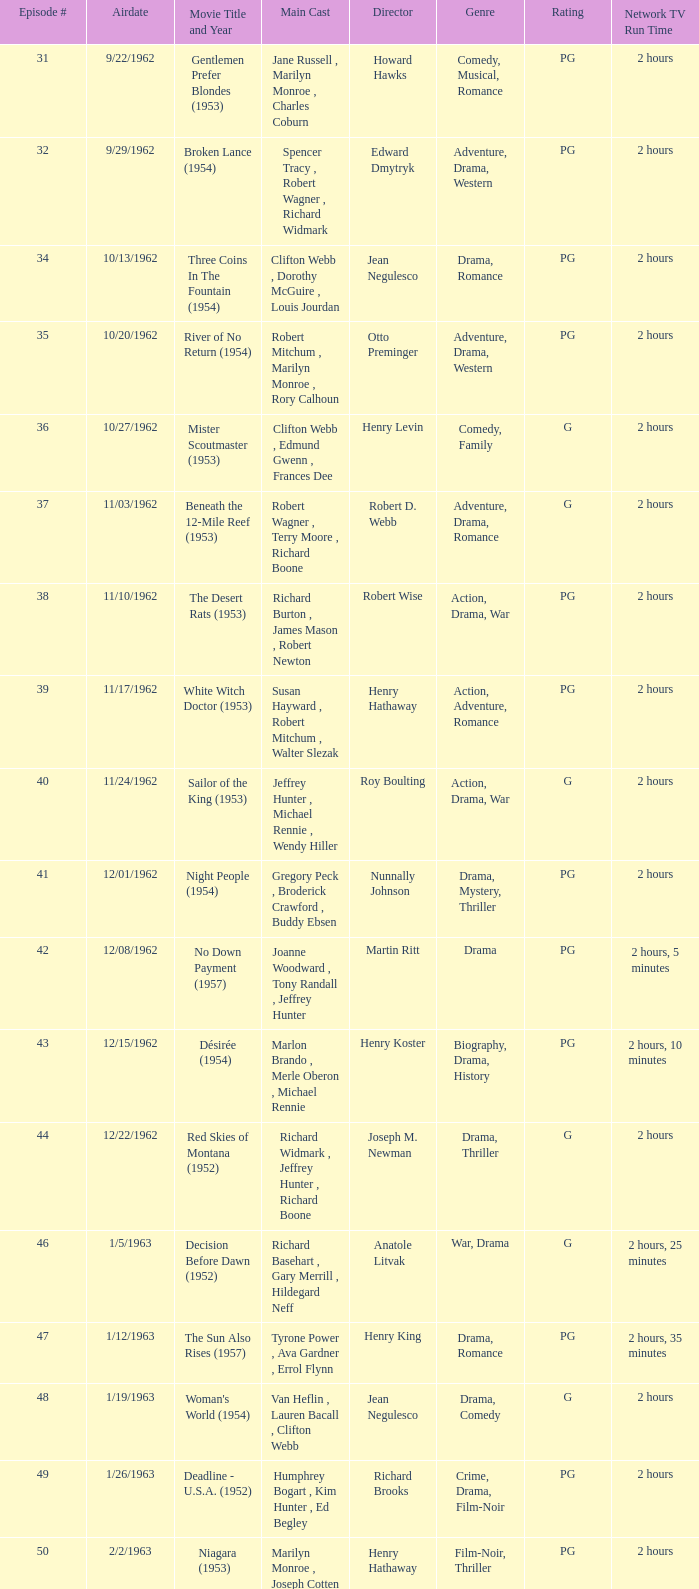What movie did dana wynter , mel ferrer , theodore bikel star in? Fraulein (1958). Would you mind parsing the complete table? {'header': ['Episode #', 'Airdate', 'Movie Title and Year', 'Main Cast', 'Director', 'Genre', 'Rating', 'Network TV Run Time'], 'rows': [['31', '9/22/1962', 'Gentlemen Prefer Blondes (1953)', 'Jane Russell , Marilyn Monroe , Charles Coburn', 'Howard Hawks', 'Comedy, Musical, Romance', 'PG', '2 hours'], ['32', '9/29/1962', 'Broken Lance (1954)', 'Spencer Tracy , Robert Wagner , Richard Widmark', 'Edward Dmytryk', 'Adventure, Drama, Western', 'PG', '2 hours'], ['34', '10/13/1962', 'Three Coins In The Fountain (1954)', 'Clifton Webb , Dorothy McGuire , Louis Jourdan', 'Jean Negulesco', 'Drama, Romance', 'PG', '2 hours'], ['35', '10/20/1962', 'River of No Return (1954)', 'Robert Mitchum , Marilyn Monroe , Rory Calhoun', 'Otto Preminger', 'Adventure, Drama, Western', 'PG', '2 hours'], ['36', '10/27/1962', 'Mister Scoutmaster (1953)', 'Clifton Webb , Edmund Gwenn , Frances Dee', 'Henry Levin', 'Comedy, Family', 'G', '2 hours'], ['37', '11/03/1962', 'Beneath the 12-Mile Reef (1953)', 'Robert Wagner , Terry Moore , Richard Boone', 'Robert D. Webb', 'Adventure, Drama, Romance', 'G', '2 hours'], ['38', '11/10/1962', 'The Desert Rats (1953)', 'Richard Burton , James Mason , Robert Newton', 'Robert Wise', 'Action, Drama, War', 'PG', '2 hours'], ['39', '11/17/1962', 'White Witch Doctor (1953)', 'Susan Hayward , Robert Mitchum , Walter Slezak', 'Henry Hathaway', 'Action, Adventure, Romance', 'PG', '2 hours'], ['40', '11/24/1962', 'Sailor of the King (1953)', 'Jeffrey Hunter , Michael Rennie , Wendy Hiller', 'Roy Boulting', 'Action, Drama, War', 'G', '2 hours'], ['41', '12/01/1962', 'Night People (1954)', 'Gregory Peck , Broderick Crawford , Buddy Ebsen', 'Nunnally Johnson', 'Drama, Mystery, Thriller', 'PG', '2 hours'], ['42', '12/08/1962', 'No Down Payment (1957)', 'Joanne Woodward , Tony Randall , Jeffrey Hunter', 'Martin Ritt', 'Drama', 'PG', '2 hours, 5 minutes'], ['43', '12/15/1962', 'Désirée (1954)', 'Marlon Brando , Merle Oberon , Michael Rennie', 'Henry Koster', 'Biography, Drama, History', 'PG', '2 hours, 10 minutes'], ['44', '12/22/1962', 'Red Skies of Montana (1952)', 'Richard Widmark , Jeffrey Hunter , Richard Boone', 'Joseph M. Newman', 'Drama, Thriller', 'G', '2 hours'], ['46', '1/5/1963', 'Decision Before Dawn (1952)', 'Richard Basehart , Gary Merrill , Hildegard Neff', 'Anatole Litvak', 'War, Drama', 'G', '2 hours, 25 minutes'], ['47', '1/12/1963', 'The Sun Also Rises (1957)', 'Tyrone Power , Ava Gardner , Errol Flynn', 'Henry King', 'Drama, Romance', 'PG', '2 hours, 35 minutes'], ['48', '1/19/1963', "Woman's World (1954)", 'Van Heflin , Lauren Bacall , Clifton Webb', 'Jean Negulesco', 'Drama, Comedy', 'G', '2 hours'], ['49', '1/26/1963', 'Deadline - U.S.A. (1952)', 'Humphrey Bogart , Kim Hunter , Ed Begley', 'Richard Brooks', 'Crime, Drama, Film-Noir', 'PG', '2 hours'], ['50', '2/2/1963', 'Niagara (1953)', 'Marilyn Monroe , Joseph Cotten , Jean Peters', 'Henry Hathaway', 'Film-Noir, Thriller', 'PG', '2 hours'], ['51', '2/9/1963', 'Kangaroo (1952)', "Maureen O'Hara , Peter Lawford , Richard Boone", 'Lewis Milestone', 'Adventure, Drama, History', 'G', '2 hours'], ['52', '2/16/1963', 'The Long Hot Summer (1958)', 'Paul Newman , Joanne Woodward , Orson Wells', 'Martin Ritt', 'Drama, Romance', 'PG', '2 hours, 15 minutes'], ['53', '2/23/1963', "The President's Lady (1953)", 'Susan Hayward , Charlton Heston , John McIntire', 'Henry Levin', 'Biography, Drama, History', 'PG', '2 hours'], ['54', '3/2/1963', 'The Roots of Heaven (1958)', 'Errol Flynn , Juliette Greco , Eddie Albert', 'John Huston', 'Adventure, Drama', 'G', '2 hours, 25 minutes'], ['55', '3/9/1963', 'In Love and War (1958)', 'Robert Wagner , Hope Lange , Jeffrey Hunter', 'Philip Dunne', 'Drama, Romance, War', 'PG', '2 hours, 10 minutes'], ['56', '3/16/1963', 'A Certain Smile (1958)', 'Rossano Brazzi , Joan Fontaine , Johnny Mathis', 'Jean Negulesco', 'Drama, Romance', 'PG', '2 hours, 5 minutes'], ['57', '3/23/1963', 'Fraulein (1958)', 'Dana Wynter , Mel Ferrer , Theodore Bikel', 'Henry Koster', 'Drama, Romance, War', 'PG', '2 hours'], ['59', '4/6/1963', 'Night and the City (1950)', 'Richard Widmark , Gene Tierney , Herbert Lom', 'Jules Dassin', 'Crime, Film-Noir, Sport', 'G', '2 hours']]} 